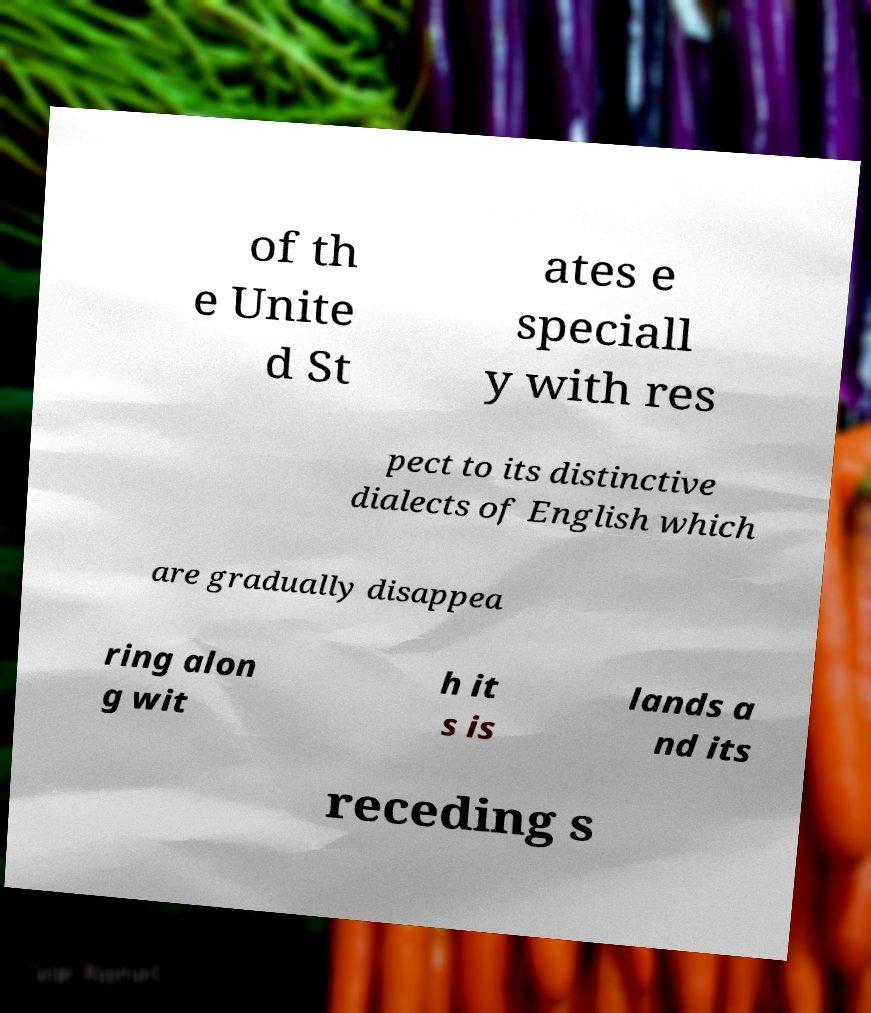What messages or text are displayed in this image? I need them in a readable, typed format. of th e Unite d St ates e speciall y with res pect to its distinctive dialects of English which are gradually disappea ring alon g wit h it s is lands a nd its receding s 